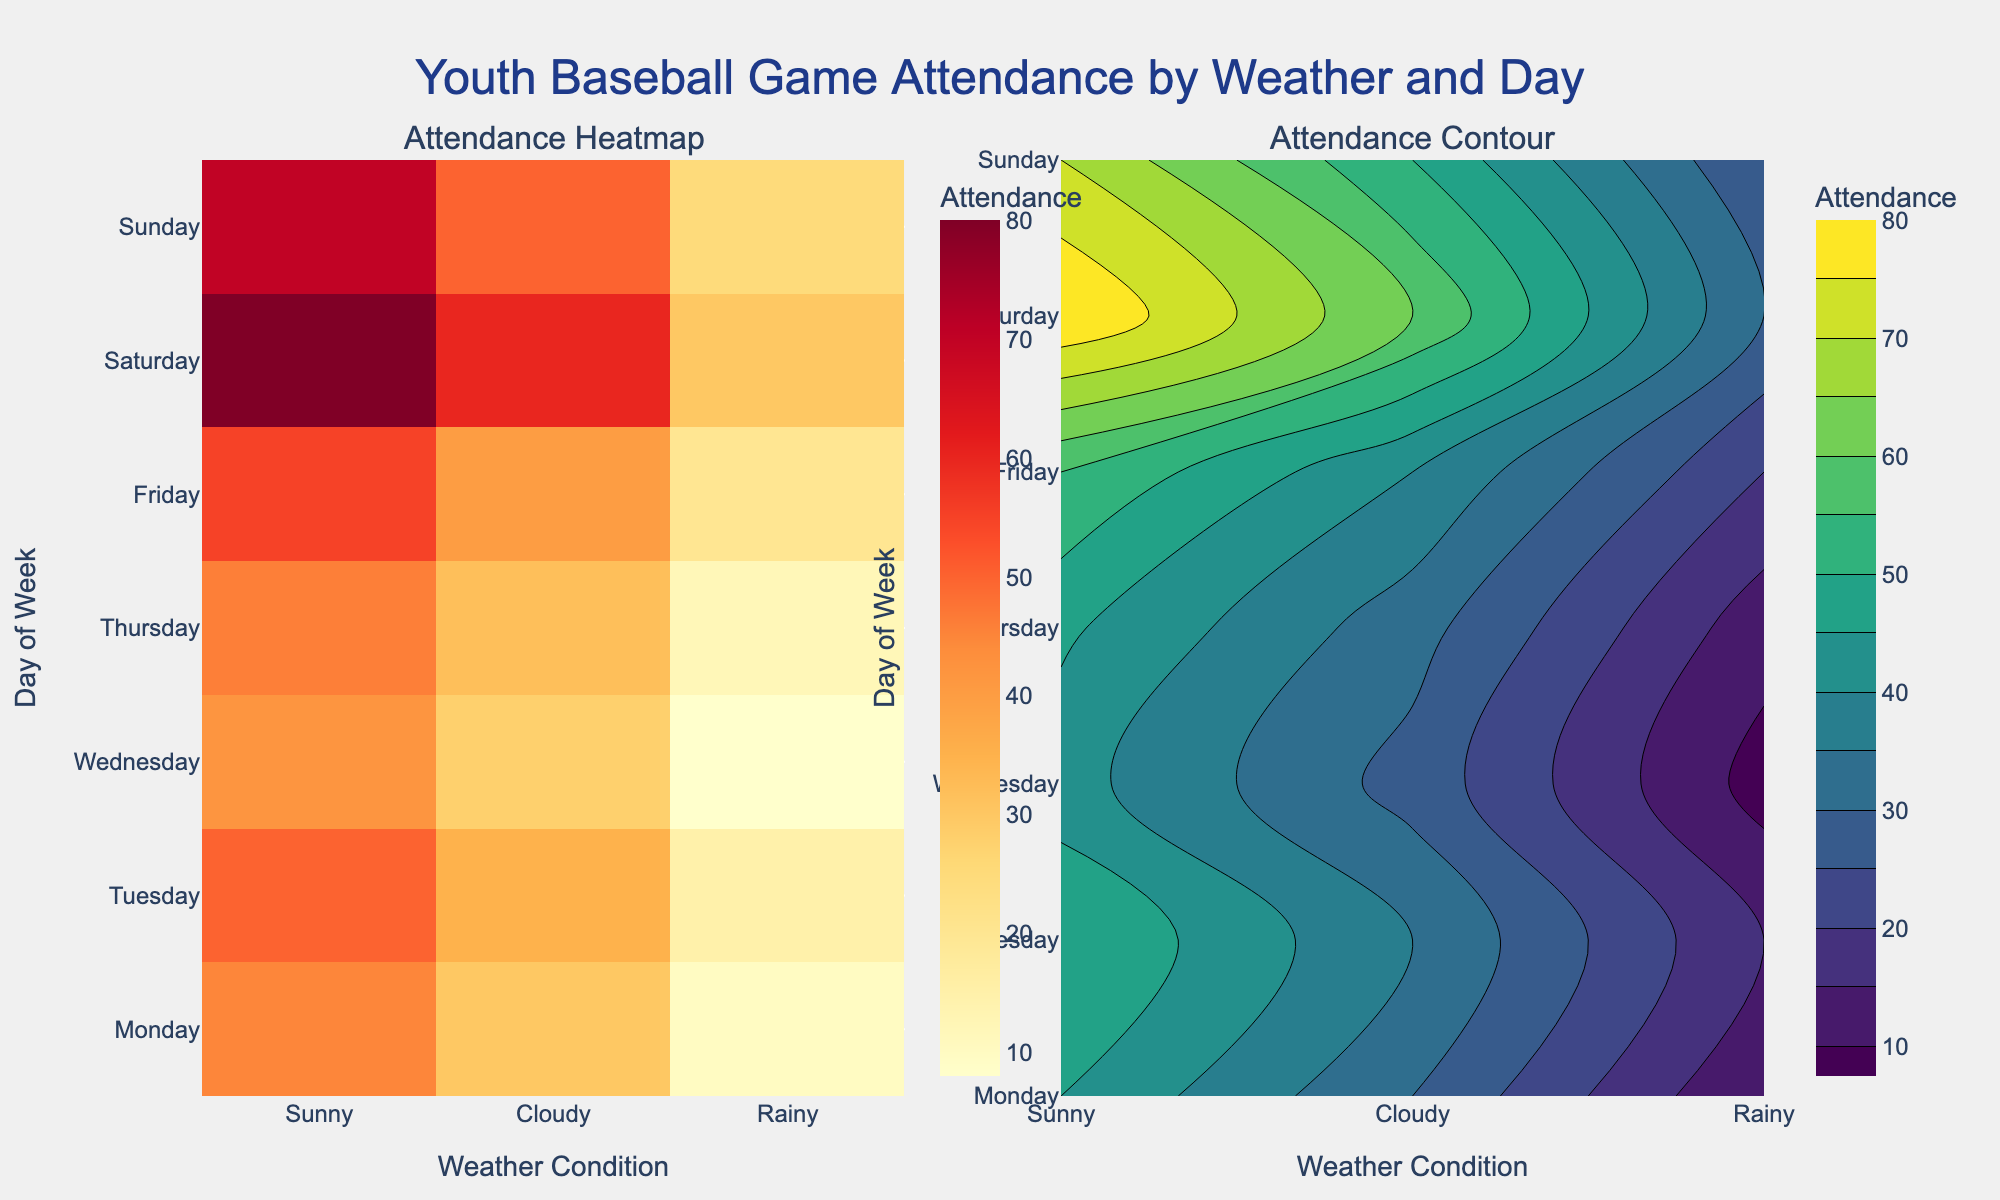What is the title of the plot? The title of the plot is displayed at the top of the figure, which provides an overview of the data being visualized—specifically focusing on the attendance at youth baseball games by weather and day.
Answer: Youth Baseball Game Attendance by Weather and Day Which day of the week has the highest attendance under sunny weather conditions? By looking at the heatmap or contour plot, you can see that the highest attendance under sunny weather conditions occurs on Saturday, with a value of 80.
Answer: Saturday What is the color scale used for the heatmap? The heatmap uses the YlOrRd color scale, which ranges from yellow to red, indicating varying levels of attendance.
Answer: YlOrRd What is the attendance difference between sunny and rainy days on Sunday? On Sunday, the average attendance for sunny weather is 70, and for rainy weather, it is 25. The difference can be calculated by subtracting 25 from 70.
Answer: 45 Which weather condition generally has the lowest attendance across all days? By glancing at the heatmap or contour plot, you can see that the rainy weather condition consistently has lower attendance compared to sunny and cloudy conditions.
Answer: Rainy On which day is the attendance for cloudy weather the highest? Observing the heatmap or contour plot, you can identify that the highest attendance for cloudy weather occurs on Saturday, with an attendance of 60.
Answer: Saturday How does attendance on Monday during sunny weather compare to attendance on Friday during cloudy weather? By comparing the heatmap or contour values, Monday's sunny weather attendance is 45, while Friday's cloudy weather attendance is 40. Thus, Monday's sunny attendance is higher by 5.
Answer: Monday's sunny attendance is higher by 5 What pattern do you notice in attendance on weekends compared to weekdays? Observing both plots reveals that attendance generally tends to be higher on weekends (Saturday and Sunday) across all weather conditions compared to weekdays.
Answer: Higher on weekends What is the attendance value on Wednesday during cloudy weather conditions? Looking at either the heatmap or contour plot, you can find that the attendance value on Wednesday during cloudy weather conditions is 28.
Answer: 28 Which subplot helps in understanding the peaks and valleys of attendance more distinctly? The contour plot helps in understanding the peaks and valleys of attendance more distinctly due to its gradient and contour lines, which visually represent variations in attendance better.
Answer: Contour plot 